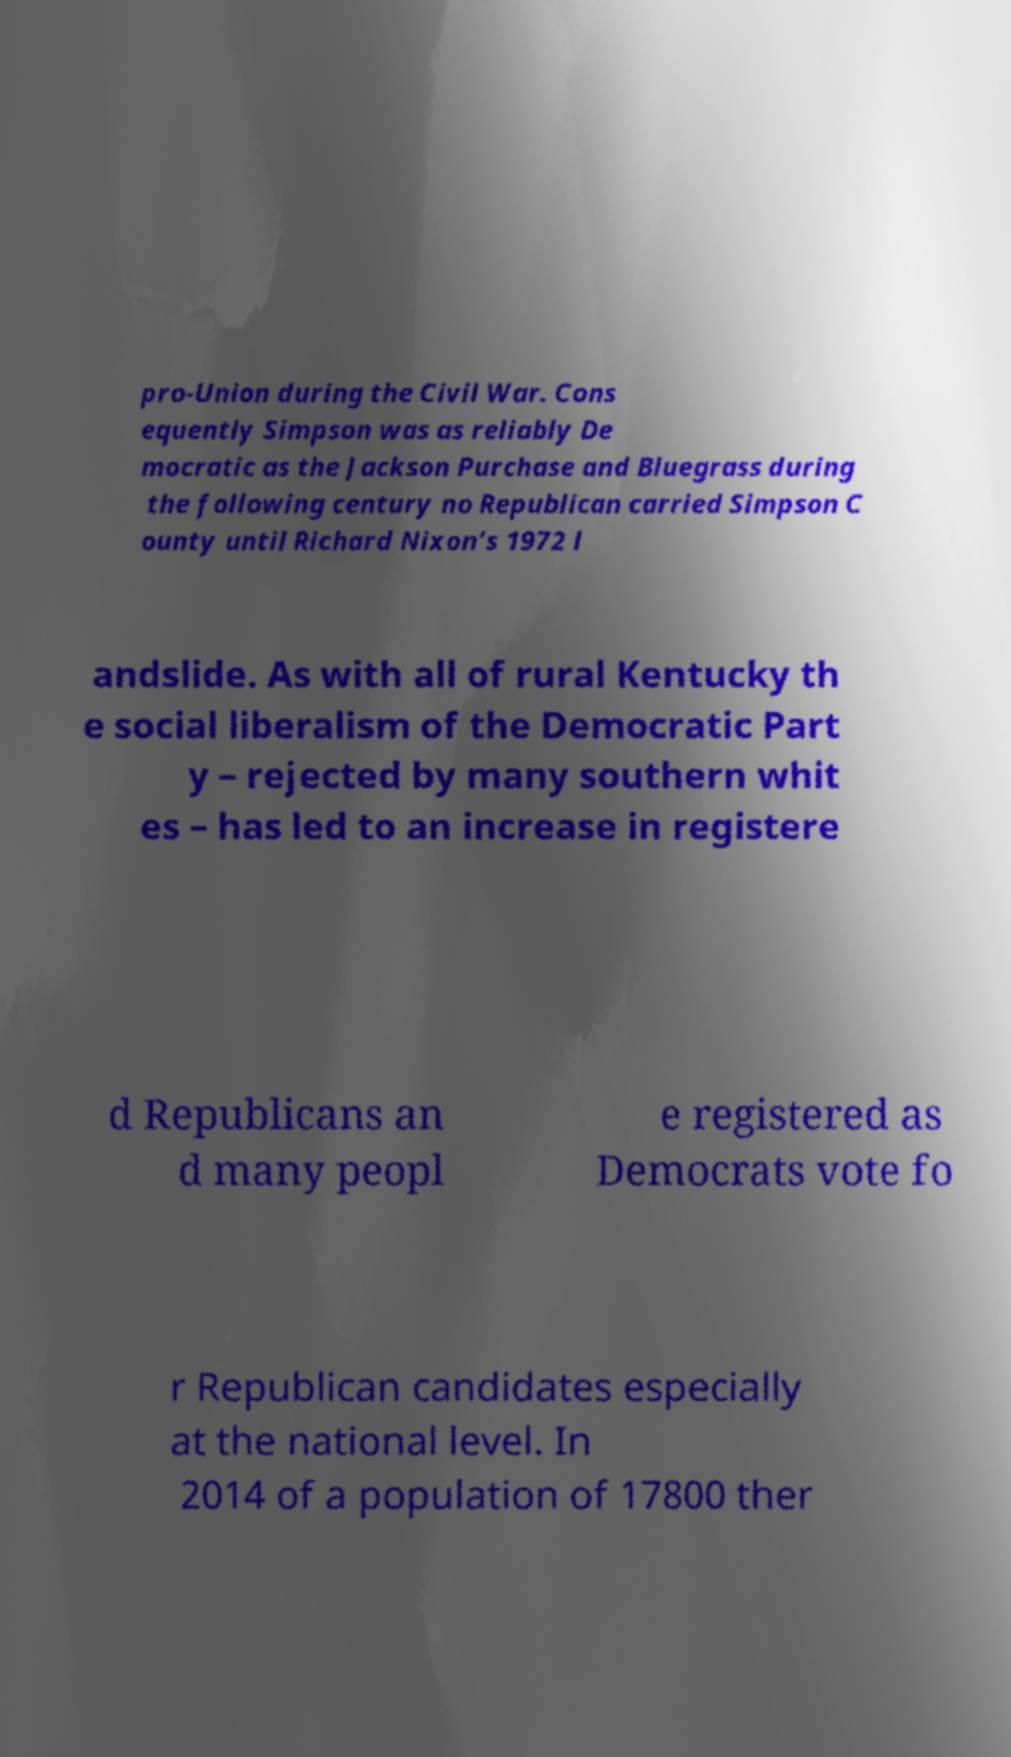Please read and relay the text visible in this image. What does it say? pro-Union during the Civil War. Cons equently Simpson was as reliably De mocratic as the Jackson Purchase and Bluegrass during the following century no Republican carried Simpson C ounty until Richard Nixon’s 1972 l andslide. As with all of rural Kentucky th e social liberalism of the Democratic Part y – rejected by many southern whit es – has led to an increase in registere d Republicans an d many peopl e registered as Democrats vote fo r Republican candidates especially at the national level. In 2014 of a population of 17800 ther 